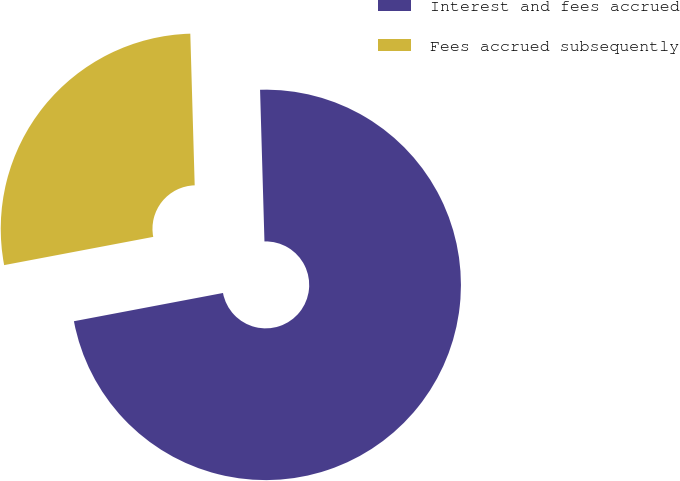Convert chart. <chart><loc_0><loc_0><loc_500><loc_500><pie_chart><fcel>Interest and fees accrued<fcel>Fees accrued subsequently<nl><fcel>72.48%<fcel>27.52%<nl></chart> 